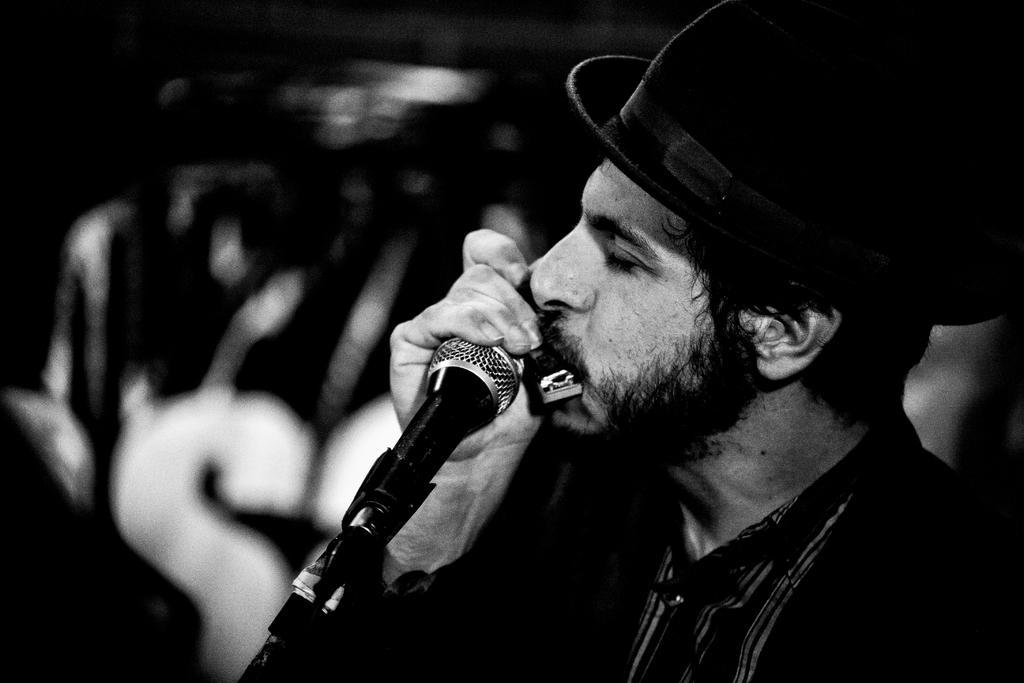How would you summarize this image in a sentence or two? In this image I can see a man holding a musical instrument. There is a mic and a stand. 